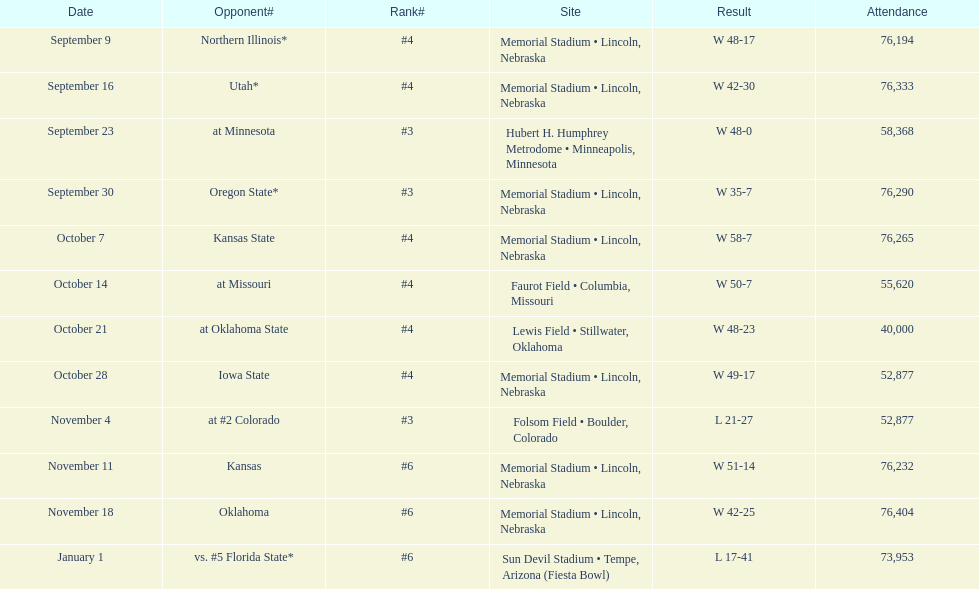Would you be able to parse every entry in this table? {'header': ['Date', 'Opponent#', 'Rank#', 'Site', 'Result', 'Attendance'], 'rows': [['September 9', 'Northern Illinois*', '#4', 'Memorial Stadium • Lincoln, Nebraska', 'W\xa048-17', '76,194'], ['September 16', 'Utah*', '#4', 'Memorial Stadium • Lincoln, Nebraska', 'W\xa042-30', '76,333'], ['September 23', 'at\xa0Minnesota', '#3', 'Hubert H. Humphrey Metrodome • Minneapolis, Minnesota', 'W\xa048-0', '58,368'], ['September 30', 'Oregon State*', '#3', 'Memorial Stadium • Lincoln, Nebraska', 'W\xa035-7', '76,290'], ['October 7', 'Kansas State', '#4', 'Memorial Stadium • Lincoln, Nebraska', 'W\xa058-7', '76,265'], ['October 14', 'at\xa0Missouri', '#4', 'Faurot Field • Columbia, Missouri', 'W\xa050-7', '55,620'], ['October 21', 'at\xa0Oklahoma State', '#4', 'Lewis Field • Stillwater, Oklahoma', 'W\xa048-23', '40,000'], ['October 28', 'Iowa State', '#4', 'Memorial Stadium • Lincoln, Nebraska', 'W\xa049-17', '52,877'], ['November 4', 'at\xa0#2\xa0Colorado', '#3', 'Folsom Field • Boulder, Colorado', 'L\xa021-27', '52,877'], ['November 11', 'Kansas', '#6', 'Memorial Stadium • Lincoln, Nebraska', 'W\xa051-14', '76,232'], ['November 18', 'Oklahoma', '#6', 'Memorial Stadium • Lincoln, Nebraska', 'W\xa042-25', '76,404'], ['January 1', 'vs.\xa0#5\xa0Florida State*', '#6', 'Sun Devil Stadium • Tempe, Arizona (Fiesta Bowl)', 'L\xa017-41', '73,953']]} How frequently does "w" occur as the result on average? 10. 